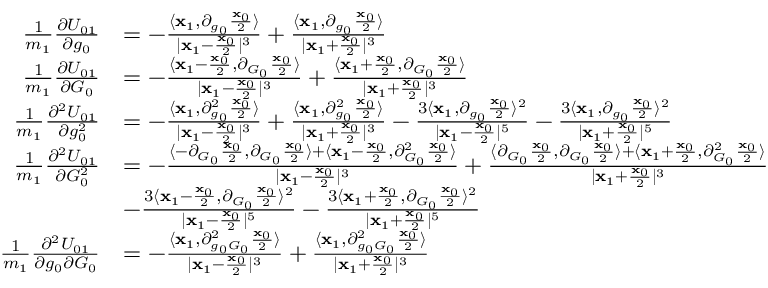<formula> <loc_0><loc_0><loc_500><loc_500>\begin{array} { r l } { \frac { 1 } { m _ { 1 } } \frac { \partial U _ { 0 1 } } { \partial g _ { 0 } } } & { = - \frac { \langle x _ { 1 } , \partial _ { g _ { 0 } } \frac { x _ { 0 } } { 2 } \rangle } { | x _ { 1 } - \frac { x _ { 0 } } { 2 } | ^ { 3 } } + \frac { \langle x _ { 1 } , \partial _ { g _ { 0 } } \frac { x _ { 0 } } { 2 } \rangle } { | x _ { 1 } + \frac { x _ { 0 } } { 2 } | ^ { 3 } } } \\ { \frac { 1 } { m _ { 1 } } \frac { \partial U _ { 0 1 } } { \partial G _ { 0 } } } & { = - \frac { \langle x _ { 1 } - \frac { x _ { 0 } } { 2 } , \partial _ { G _ { 0 } } \frac { x _ { 0 } } { 2 } \rangle } { | x _ { 1 } - \frac { x _ { 0 } } { 2 } | ^ { 3 } } + \frac { \langle x _ { 1 } + \frac { x _ { 0 } } { 2 } , \partial _ { G _ { 0 } } \frac { x _ { 0 } } { 2 } \rangle } { | x _ { 1 } + \frac { x _ { 0 } } { 2 } | ^ { 3 } } } \\ { \frac { 1 } { m _ { 1 } } \frac { \partial ^ { 2 } U _ { 0 1 } } { \partial g _ { 0 } ^ { 2 } } } & { = - \frac { \langle x _ { 1 } , \partial _ { g _ { 0 } } ^ { 2 } \frac { x _ { 0 } } { 2 } \rangle } { | x _ { 1 } - \frac { x _ { 0 } } { 2 } | ^ { 3 } } + \frac { \langle x _ { 1 } , \partial _ { g _ { 0 } } ^ { 2 } \frac { x _ { 0 } } { 2 } \rangle } { | x _ { 1 } + \frac { x _ { 0 } } { 2 } | ^ { 3 } } - \frac { 3 \langle x _ { 1 } , \partial _ { g _ { 0 } } \frac { x _ { 0 } } { 2 } \rangle ^ { 2 } } { | x _ { 1 } - \frac { x _ { 0 } } { 2 } | ^ { 5 } } - \frac { 3 \langle x _ { 1 } , \partial _ { g _ { 0 } } \frac { x _ { 0 } } { 2 } \rangle ^ { 2 } } { | x _ { 1 } + \frac { x _ { 0 } } { 2 } | ^ { 5 } } } \\ { \frac { 1 } { m _ { 1 } } \frac { \partial ^ { 2 } U _ { 0 1 } } { \partial G _ { 0 } ^ { 2 } } } & { = - \frac { \langle - \partial _ { G _ { 0 } } \frac { x _ { 0 } } { 2 } , \partial _ { G _ { 0 } } \frac { x _ { 0 } } { 2 } \rangle + \langle x _ { 1 } - \frac { x _ { 0 } } { 2 } , \partial _ { G _ { 0 } } ^ { 2 } \frac { x _ { 0 } } { 2 } \rangle } { | x _ { 1 } - \frac { x _ { 0 } } { 2 } | ^ { 3 } } + \frac { \langle \partial _ { G _ { 0 } } \frac { x _ { 0 } } { 2 } , \partial _ { G _ { 0 } } \frac { x _ { 0 } } { 2 } \rangle + \langle x _ { 1 } + \frac { x _ { 0 } } { 2 } , \partial _ { G _ { 0 } } ^ { 2 } \frac { x _ { 0 } } { 2 } \rangle } { | x _ { 1 } + \frac { x _ { 0 } } { 2 } | ^ { 3 } } } \\ & { - \frac { 3 \langle x _ { 1 } - \frac { x _ { 0 } } { 2 } , \partial _ { G _ { 0 } } \frac { x _ { 0 } } { 2 } \rangle ^ { 2 } } { | x _ { 1 } - \frac { x _ { 0 } } { 2 } | ^ { 5 } } - \frac { 3 \langle x _ { 1 } + \frac { x _ { 0 } } { 2 } , \partial _ { G _ { 0 } } \frac { x _ { 0 } } { 2 } \rangle ^ { 2 } } { | x _ { 1 } + \frac { x _ { 0 } } { 2 } | ^ { 5 } } } \\ { \frac { 1 } { m _ { 1 } } \frac { \partial ^ { 2 } U _ { 0 1 } } { \partial g _ { 0 } \partial G _ { 0 } } } & { = - \frac { \langle x _ { 1 } , \partial _ { g _ { 0 } G _ { 0 } } ^ { 2 } \frac { x _ { 0 } } { 2 } \rangle } { | x _ { 1 } - \frac { x _ { 0 } } { 2 } | ^ { 3 } } + \frac { \langle x _ { 1 } , \partial _ { g _ { 0 } G _ { 0 } } ^ { 2 } \frac { x _ { 0 } } { 2 } \rangle } { | x _ { 1 } + \frac { x _ { 0 } } { 2 } | ^ { 3 } } } \end{array}</formula> 